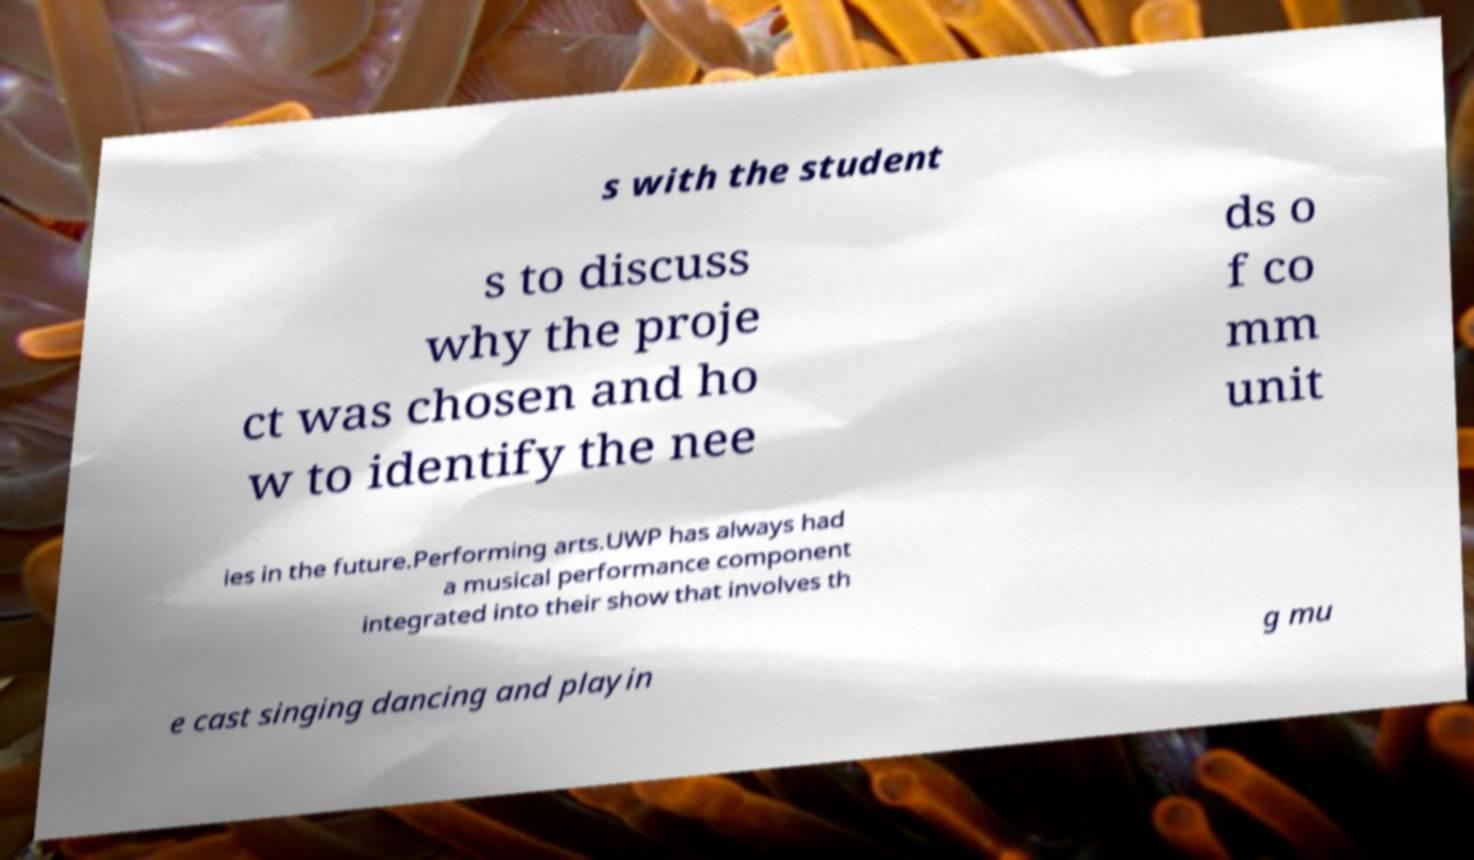Could you assist in decoding the text presented in this image and type it out clearly? s with the student s to discuss why the proje ct was chosen and ho w to identify the nee ds o f co mm unit ies in the future.Performing arts.UWP has always had a musical performance component integrated into their show that involves th e cast singing dancing and playin g mu 